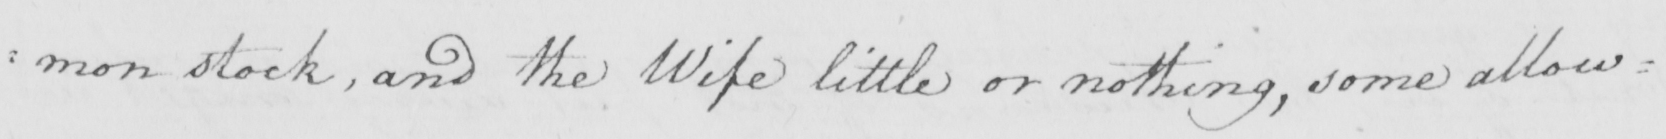What does this handwritten line say? : mon stock , and the wife little or nothing , some allow= 